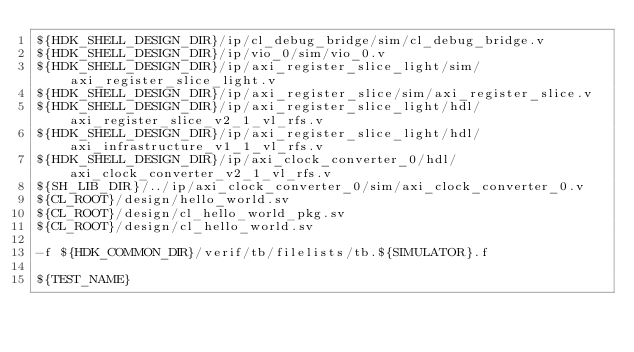Convert code to text. <code><loc_0><loc_0><loc_500><loc_500><_FORTRAN_>${HDK_SHELL_DESIGN_DIR}/ip/cl_debug_bridge/sim/cl_debug_bridge.v
${HDK_SHELL_DESIGN_DIR}/ip/vio_0/sim/vio_0.v
${HDK_SHELL_DESIGN_DIR}/ip/axi_register_slice_light/sim/axi_register_slice_light.v
${HDK_SHELL_DESIGN_DIR}/ip/axi_register_slice/sim/axi_register_slice.v
${HDK_SHELL_DESIGN_DIR}/ip/axi_register_slice_light/hdl/axi_register_slice_v2_1_vl_rfs.v
${HDK_SHELL_DESIGN_DIR}/ip/axi_register_slice_light/hdl/axi_infrastructure_v1_1_vl_rfs.v
${HDK_SHELL_DESIGN_DIR}/ip/axi_clock_converter_0/hdl/axi_clock_converter_v2_1_vl_rfs.v
${SH_LIB_DIR}/../ip/axi_clock_converter_0/sim/axi_clock_converter_0.v
${CL_ROOT}/design/hello_world.sv
${CL_ROOT}/design/cl_hello_world_pkg.sv
${CL_ROOT}/design/cl_hello_world.sv

-f ${HDK_COMMON_DIR}/verif/tb/filelists/tb.${SIMULATOR}.f

${TEST_NAME}
</code> 